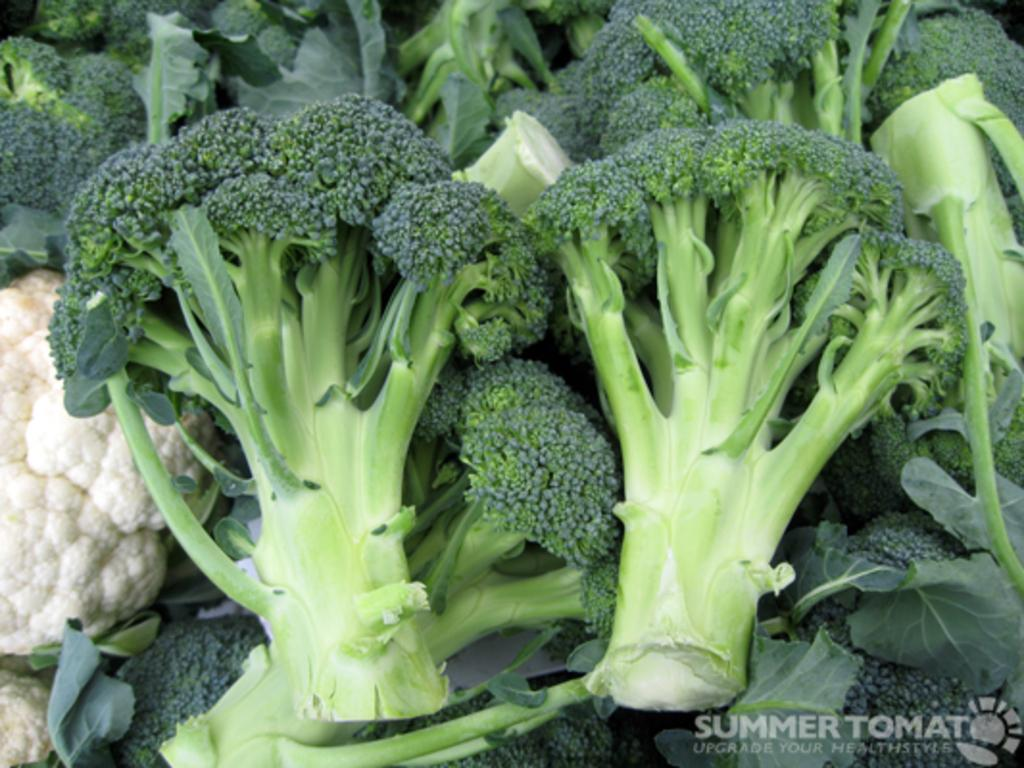What type of vegetable can be seen in the image? There is broccoli in the image. Are there any other vegetables present in the image? Yes, there is cauliflower in the image. What color bead is hanging from the cauliflower in the image? There are no beads present in the image, and the cauliflower is not adorned with any decorations. What type of calculations can be performed using the broccoli in the image? The broccoli in the image is not a calculator and cannot be used for performing calculations. 